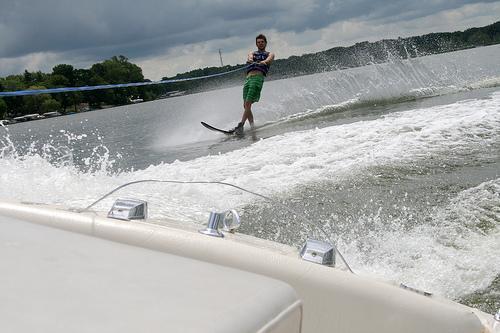How many people are water skiing?
Give a very brief answer. 1. 